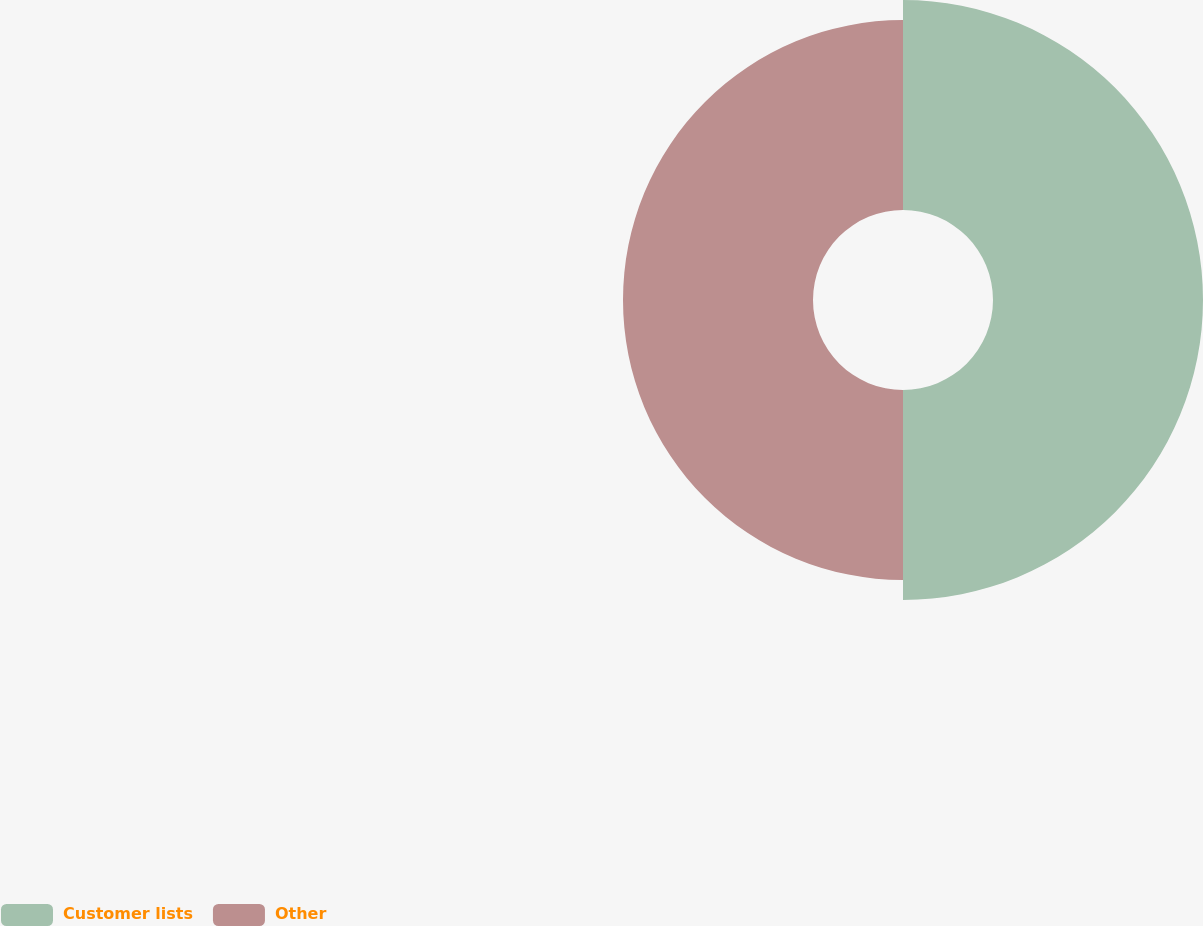<chart> <loc_0><loc_0><loc_500><loc_500><pie_chart><fcel>Customer lists<fcel>Other<nl><fcel>52.5%<fcel>47.5%<nl></chart> 